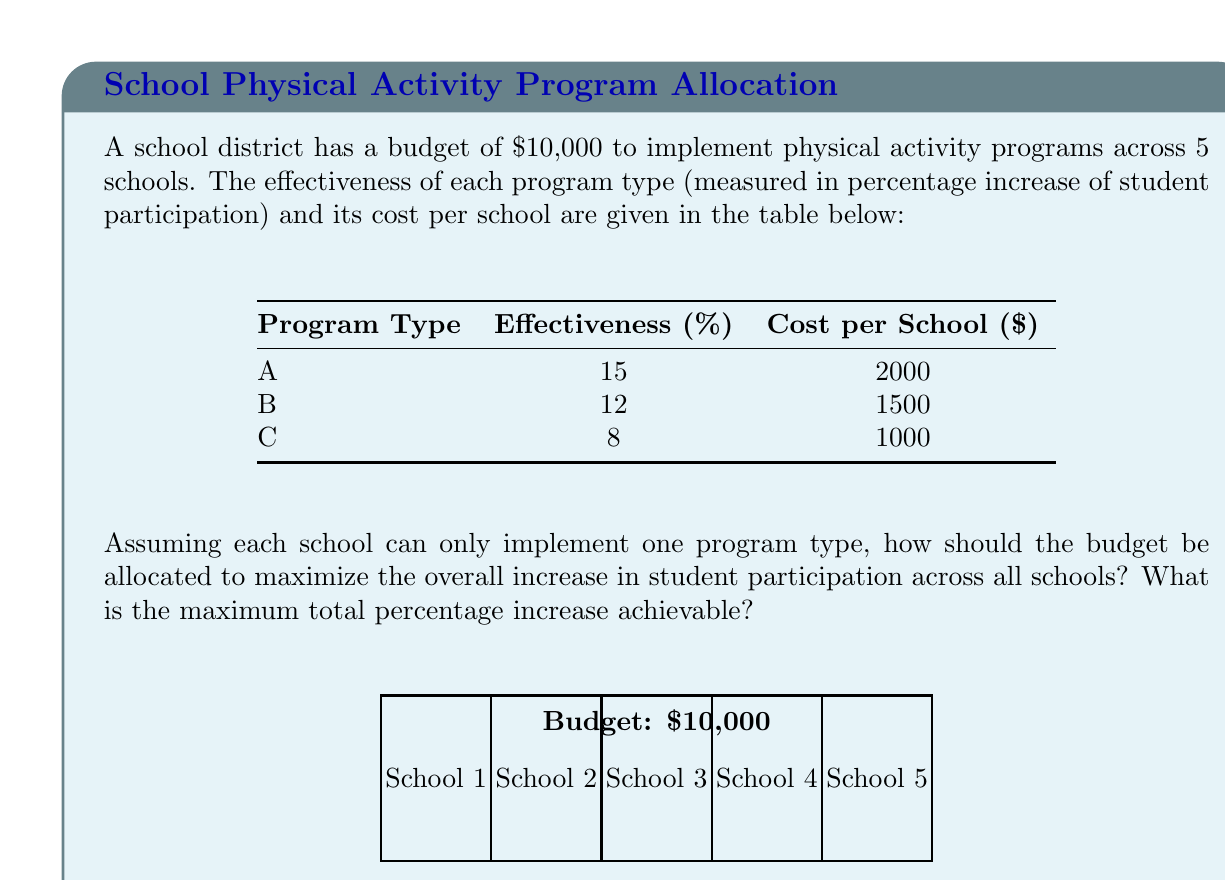Could you help me with this problem? Let's approach this step-by-step using integer programming:

1) Define variables:
   Let $x_i$, $y_i$, and $z_i$ be binary variables for school $i$ ($i = 1,2,3,4,5$)
   where 1 indicates the program is implemented, 0 otherwise.
   
   $x_i$: Program A
   $y_i$: Program B
   $z_i$: Program C

2) Objective function:
   Maximize $\sum_{i=1}^5 (15x_i + 12y_i + 8z_i)$

3) Constraints:
   a) Budget: $\sum_{i=1}^5 (2000x_i + 1500y_i + 1000z_i) \leq 10000$
   b) One program per school: $x_i + y_i + z_i = 1$ for each $i$
   c) Binary constraints: $x_i, y_i, z_i \in \{0,1\}$

4) Solving:
   This is a small problem, so we can solve it by enumeration.
   The optimal solution is to implement:
   - Program A in 3 schools (3 * 2000 = 6000)
   - Program B in 2 schools (2 * 1500 = 3000)
   Total cost: 6000 + 3000 = 9000 ≤ 10000

5) Calculating the total percentage increase:
   (3 * 15%) + (2 * 12%) = 45% + 24% = 69%

Therefore, the maximum total percentage increase achievable is 69%.
Answer: 69% 